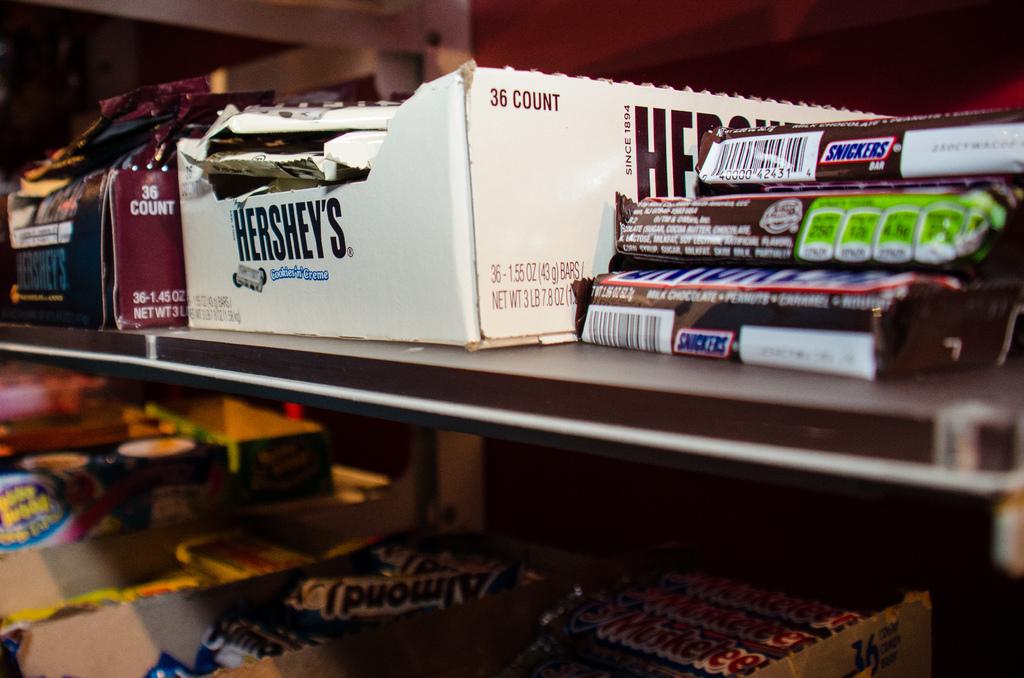What is the brand in the white box?
Offer a very short reply. Hershey's. 